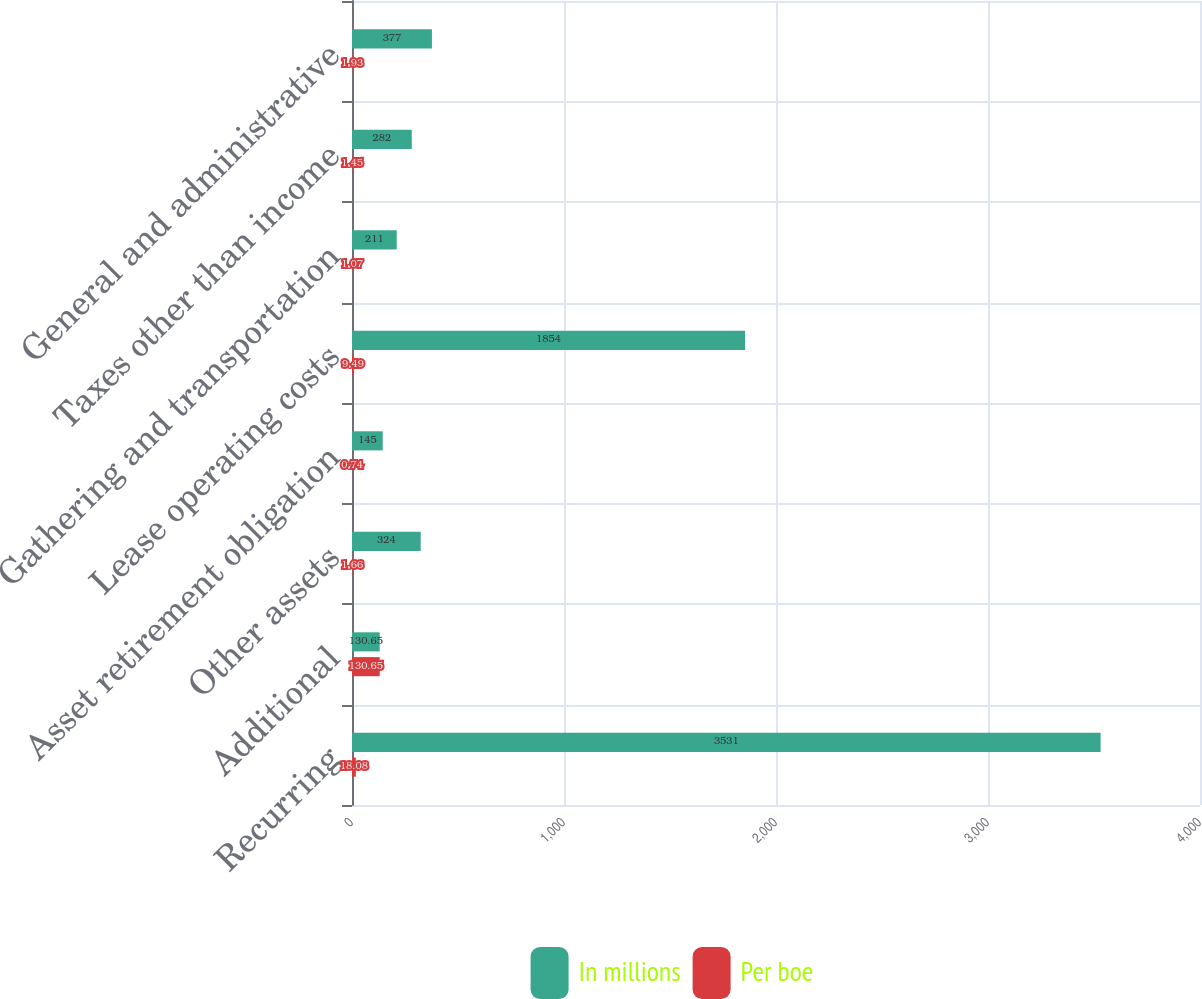Convert chart. <chart><loc_0><loc_0><loc_500><loc_500><stacked_bar_chart><ecel><fcel>Recurring<fcel>Additional<fcel>Other assets<fcel>Asset retirement obligation<fcel>Lease operating costs<fcel>Gathering and transportation<fcel>Taxes other than income<fcel>General and administrative<nl><fcel>In millions<fcel>3531<fcel>130.65<fcel>324<fcel>145<fcel>1854<fcel>211<fcel>282<fcel>377<nl><fcel>Per boe<fcel>18.08<fcel>130.65<fcel>1.66<fcel>0.74<fcel>9.49<fcel>1.07<fcel>1.45<fcel>1.93<nl></chart> 